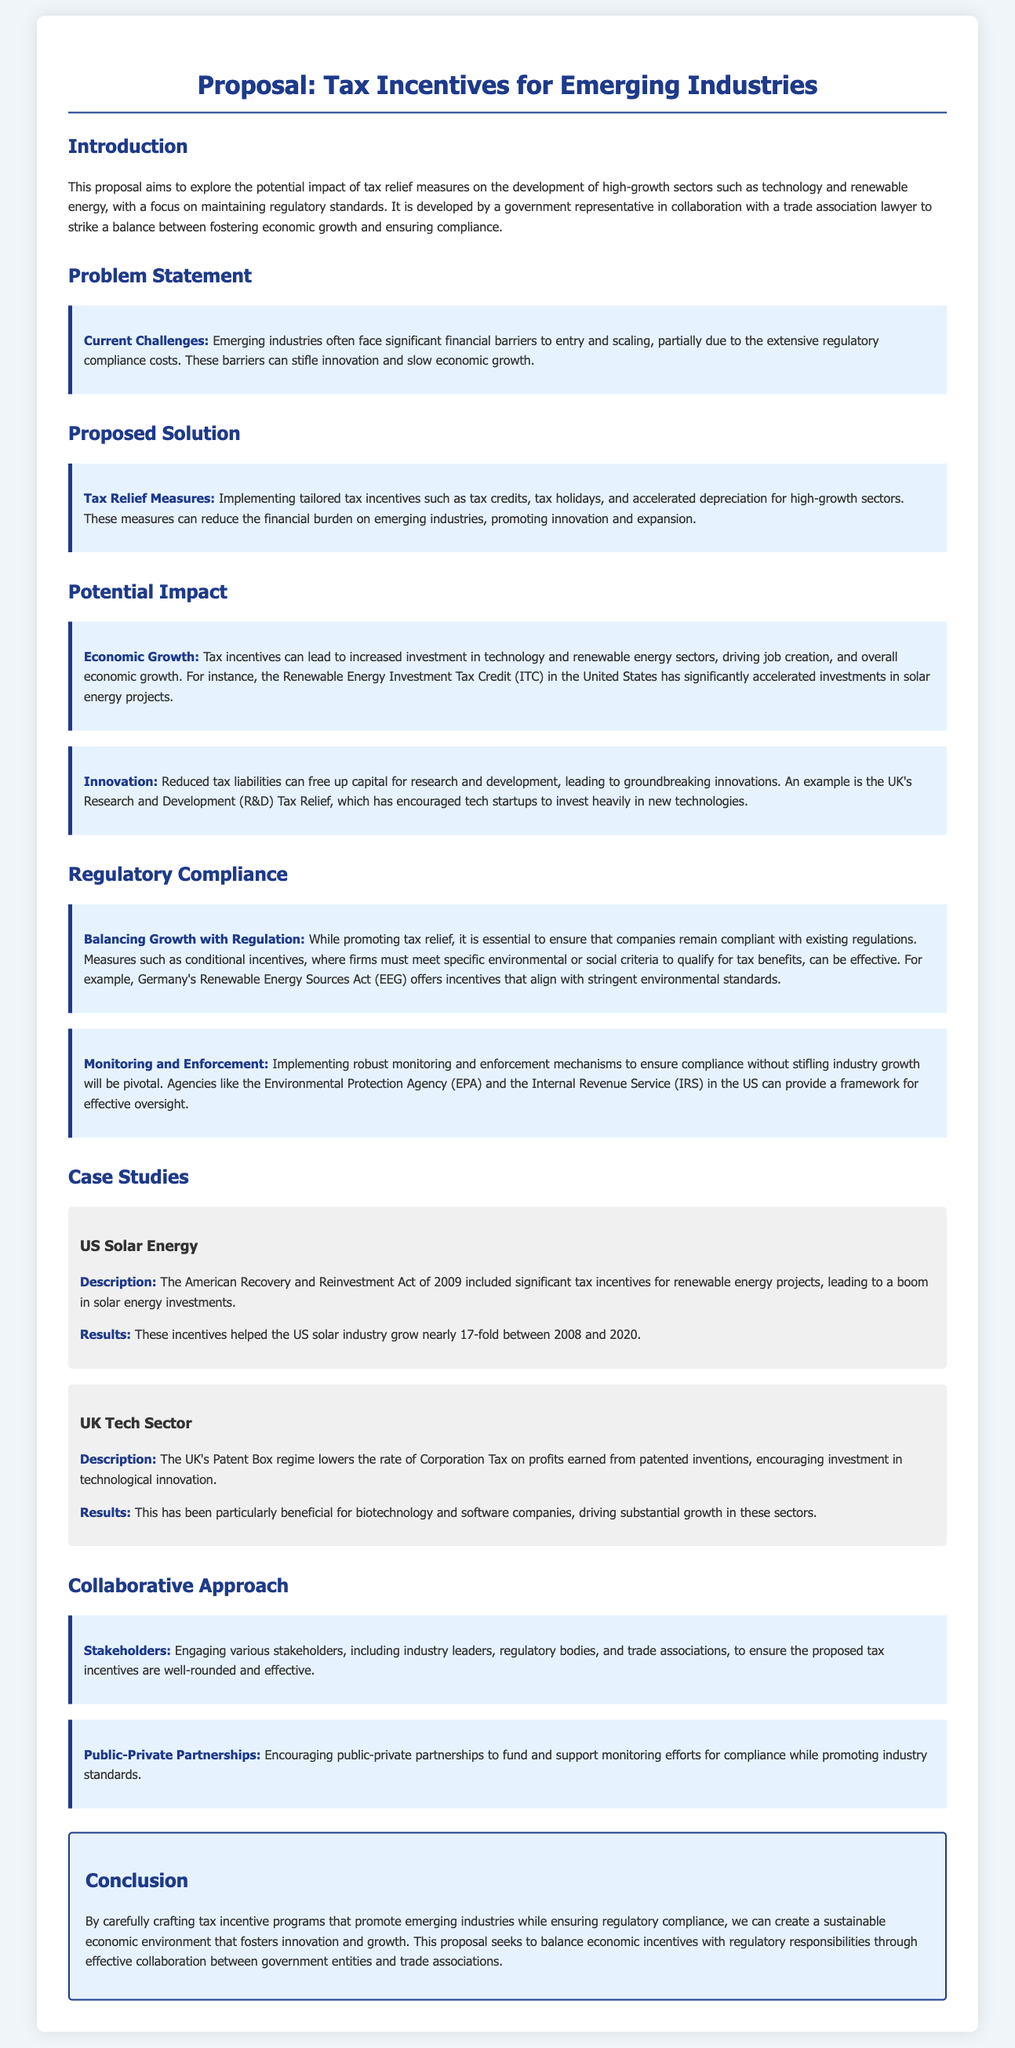What is the main goal of the proposal? The proposal aims to explore the potential impact of tax relief measures on the development of high-growth sectors such as technology and renewable energy.
Answer: To explore the potential impact of tax relief measures What are the current challenges faced by emerging industries? Current challenges include significant financial barriers to entry and scaling, partly due to extensive regulatory compliance costs.
Answer: Financial barriers and regulatory compliance costs What type of tax relief measures are proposed? The proposed tax relief measures include tailored tax incentives such as tax credits, tax holidays, and accelerated depreciation.
Answer: Tax credits, tax holidays, and accelerated depreciation What example is given for economic growth in the technology sector? An example is the UK's Research and Development (R&D) Tax Relief, which has encouraged tech startups to invest heavily in new technologies.
Answer: UK's Research and Development (R&D) Tax Relief How much did the US solar industry grow between 2008 and 2020? The US solar industry grew nearly 17-fold between 2008 and 2020.
Answer: Nearly 17-fold What method does the proposal suggest for balancing growth with regulations? Measures such as conditional incentives, where firms must meet specific environmental or social criteria to qualify for tax benefits, can be effective.
Answer: Conditional incentives What is a key focus area for monitoring compliance? A key focus area is implementing robust monitoring and enforcement mechanisms.
Answer: Robust monitoring and enforcement mechanisms Which two agencies are mentioned for providing effective oversight? The Environmental Protection Agency (EPA) and the Internal Revenue Service (IRS) in the US.
Answer: EPA and IRS 